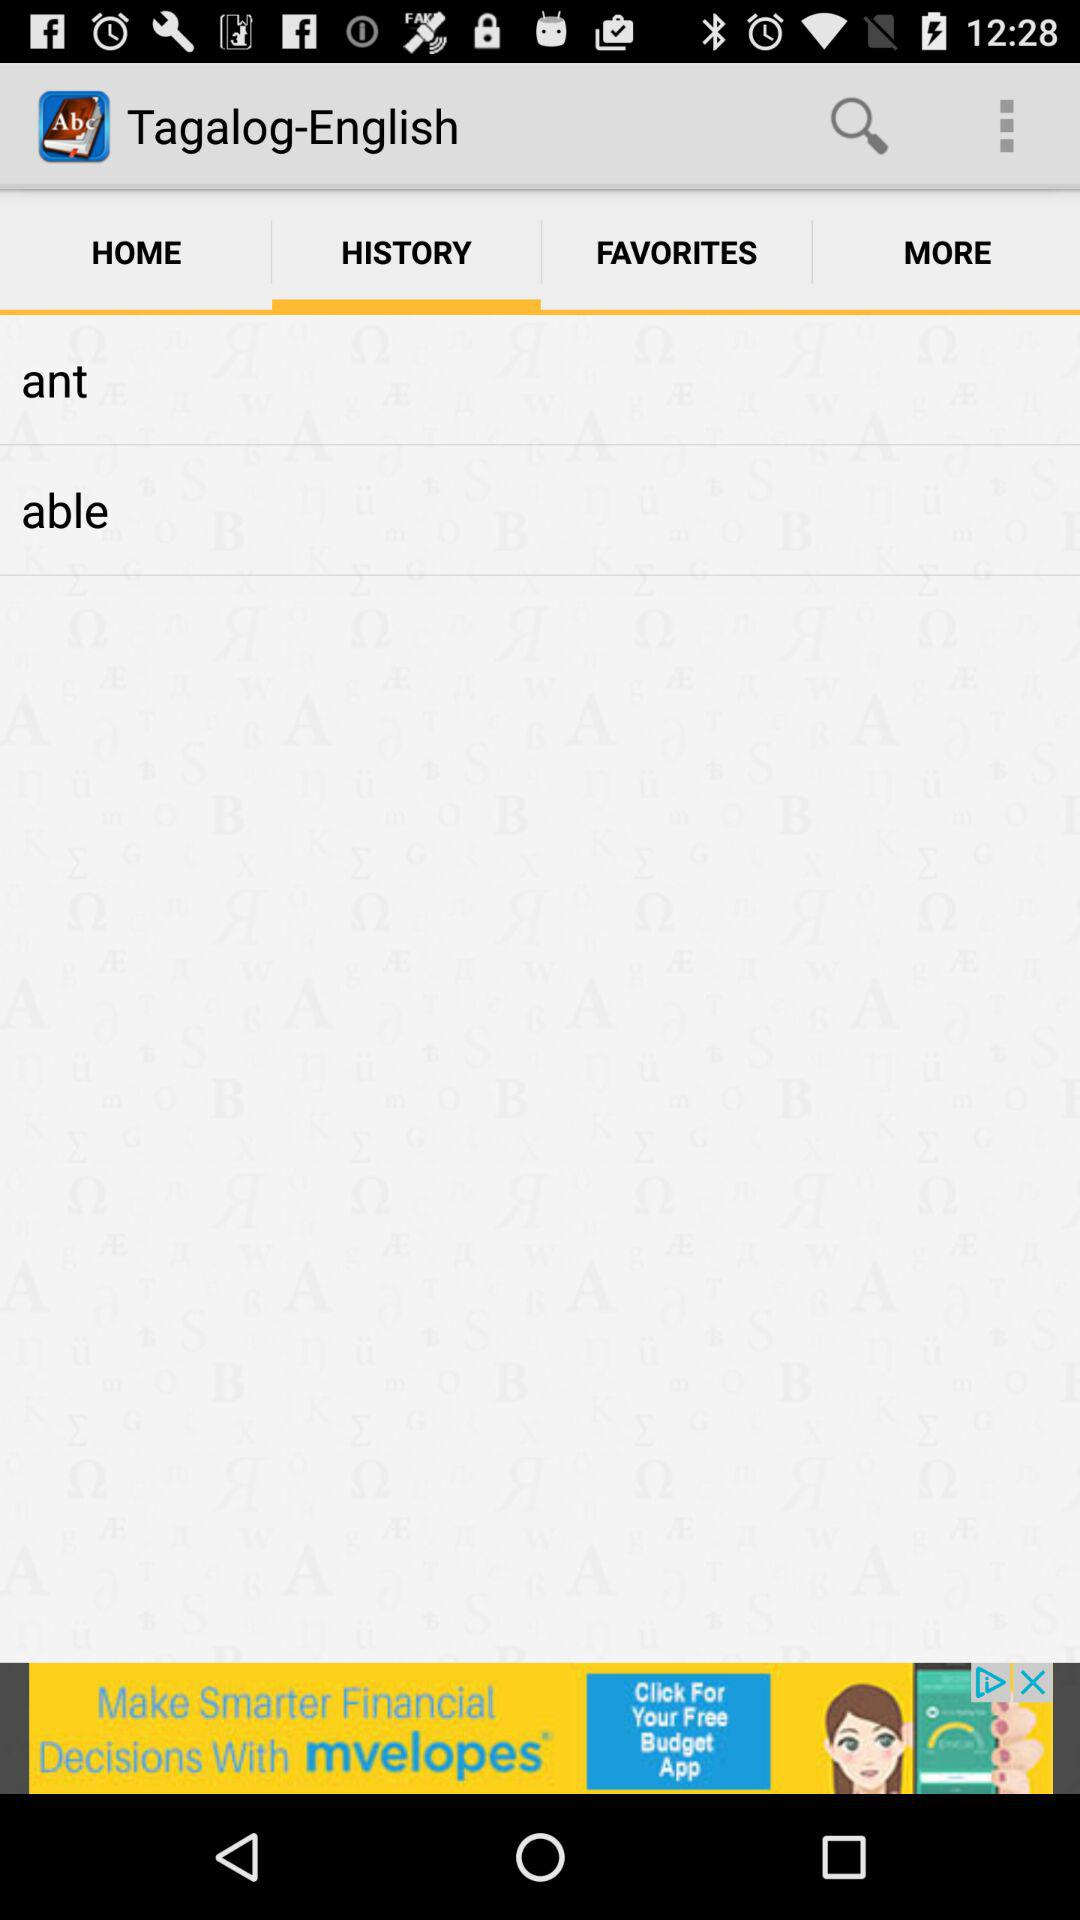Which option is selected in "Tagalog-English"? The selected option in "Tagalog-English" is "HISTORY". 